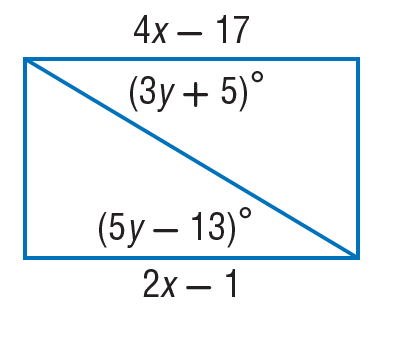Answer the mathemtical geometry problem and directly provide the correct option letter.
Question: Find x so that the quadrilateral is a parallelogram.
Choices: A: 8 B: 9 C: 18 D: 19 A 